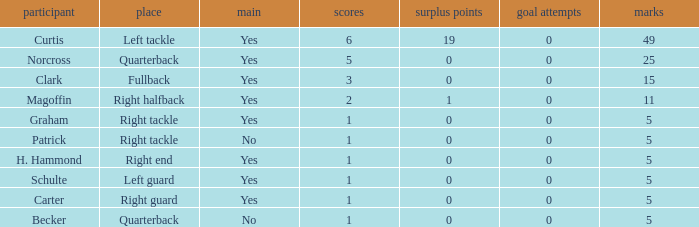Name the number of field goals for 19 extra points 1.0. Could you help me parse every detail presented in this table? {'header': ['participant', 'place', 'main', 'scores', 'surplus points', 'goal attempts', 'marks'], 'rows': [['Curtis', 'Left tackle', 'Yes', '6', '19', '0', '49'], ['Norcross', 'Quarterback', 'Yes', '5', '0', '0', '25'], ['Clark', 'Fullback', 'Yes', '3', '0', '0', '15'], ['Magoffin', 'Right halfback', 'Yes', '2', '1', '0', '11'], ['Graham', 'Right tackle', 'Yes', '1', '0', '0', '5'], ['Patrick', 'Right tackle', 'No', '1', '0', '0', '5'], ['H. Hammond', 'Right end', 'Yes', '1', '0', '0', '5'], ['Schulte', 'Left guard', 'Yes', '1', '0', '0', '5'], ['Carter', 'Right guard', 'Yes', '1', '0', '0', '5'], ['Becker', 'Quarterback', 'No', '1', '0', '0', '5']]} 